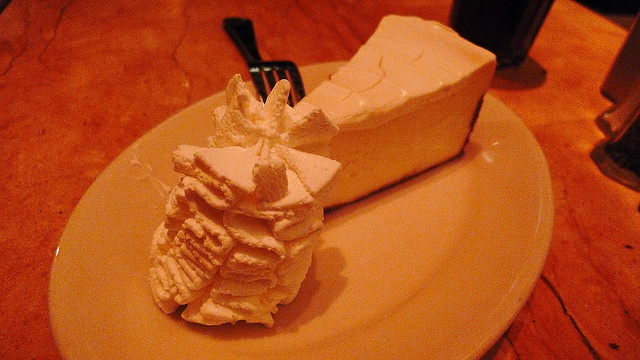Describe the objects in this image and their specific colors. I can see dining table in brown, red, orange, and black tones, cake in maroon, red, orange, and brown tones, cake in maroon, orange, red, and brown tones, and fork in maroon, black, and olive tones in this image. 